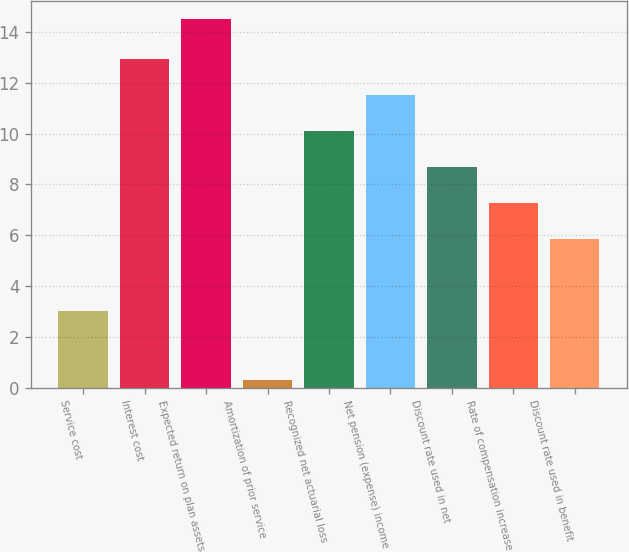<chart> <loc_0><loc_0><loc_500><loc_500><bar_chart><fcel>Service cost<fcel>Interest cost<fcel>Expected return on plan assets<fcel>Amortization of prior service<fcel>Recognized net actuarial loss<fcel>Net pension (expense) income<fcel>Discount rate used in net<fcel>Rate of compensation increase<fcel>Discount rate used in benefit<nl><fcel>3<fcel>12.94<fcel>14.5<fcel>0.3<fcel>10.1<fcel>11.52<fcel>8.68<fcel>7.26<fcel>5.84<nl></chart> 